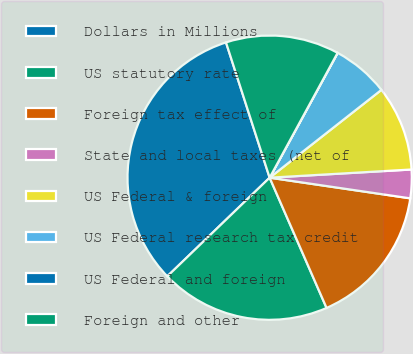Convert chart. <chart><loc_0><loc_0><loc_500><loc_500><pie_chart><fcel>Dollars in Millions<fcel>US statutory rate<fcel>Foreign tax effect of<fcel>State and local taxes (net of<fcel>US Federal & foreign<fcel>US Federal research tax credit<fcel>US Federal and foreign<fcel>Foreign and other<nl><fcel>32.24%<fcel>19.35%<fcel>16.12%<fcel>3.24%<fcel>9.68%<fcel>6.46%<fcel>0.01%<fcel>12.9%<nl></chart> 